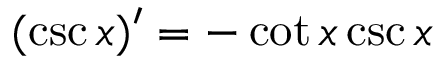<formula> <loc_0><loc_0><loc_500><loc_500>( \csc x ) ^ { \prime } = - \cot x \csc x</formula> 